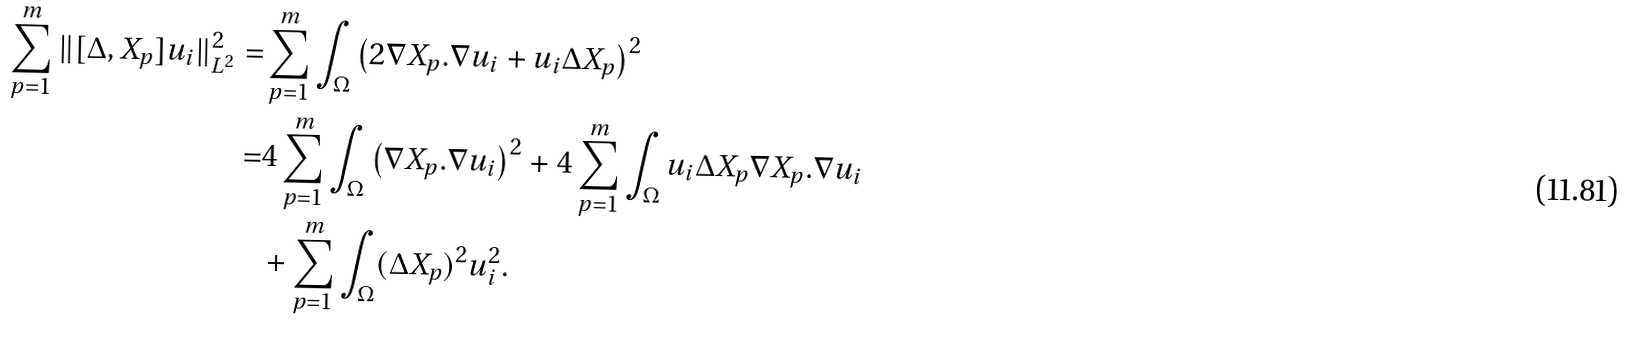<formula> <loc_0><loc_0><loc_500><loc_500>\sum _ { p = 1 } ^ { m } \| [ \Delta , X _ { p } ] u _ { i } \| _ { L ^ { 2 } } ^ { 2 } = & \sum _ { p = 1 } ^ { m } \int _ { \Omega } \left ( 2 \nabla X _ { p } . \nabla u _ { i } + u _ { i } \Delta X _ { p } \right ) ^ { 2 } \\ = & 4 \sum _ { p = 1 } ^ { m } \int _ { \Omega } \left ( \nabla X _ { p } . \nabla u _ { i } \right ) ^ { 2 } + 4 \sum _ { p = 1 } ^ { m } \int _ { \Omega } u _ { i } \Delta X _ { p } \nabla X _ { p } . \nabla u _ { i } \\ & + \sum _ { p = 1 } ^ { m } \int _ { \Omega } ( \Delta X _ { p } ) ^ { 2 } u _ { i } ^ { 2 } .</formula> 